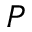Convert formula to latex. <formula><loc_0><loc_0><loc_500><loc_500>_ { P }</formula> 